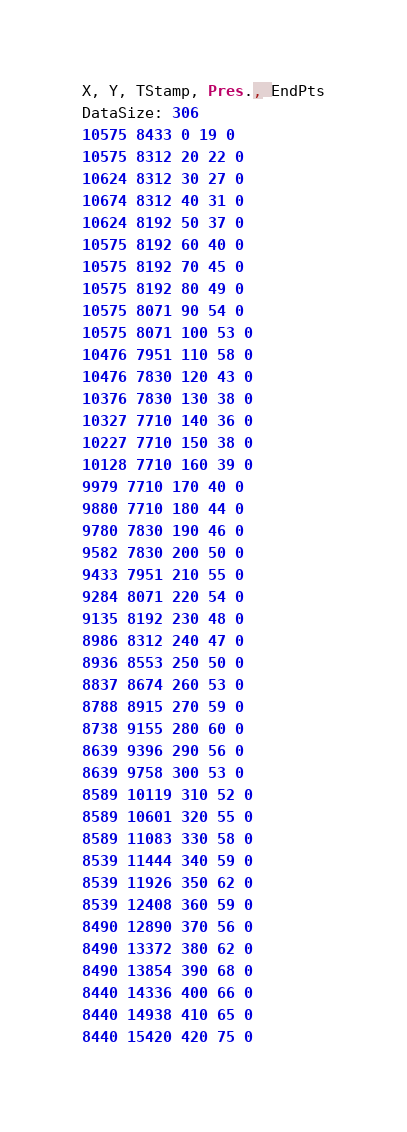<code> <loc_0><loc_0><loc_500><loc_500><_SML_>X, Y, TStamp, Pres., EndPts
DataSize: 306
10575 8433 0 19 0
10575 8312 20 22 0
10624 8312 30 27 0
10674 8312 40 31 0
10624 8192 50 37 0
10575 8192 60 40 0
10575 8192 70 45 0
10575 8192 80 49 0
10575 8071 90 54 0
10575 8071 100 53 0
10476 7951 110 58 0
10476 7830 120 43 0
10376 7830 130 38 0
10327 7710 140 36 0
10227 7710 150 38 0
10128 7710 160 39 0
9979 7710 170 40 0
9880 7710 180 44 0
9780 7830 190 46 0
9582 7830 200 50 0
9433 7951 210 55 0
9284 8071 220 54 0
9135 8192 230 48 0
8986 8312 240 47 0
8936 8553 250 50 0
8837 8674 260 53 0
8788 8915 270 59 0
8738 9155 280 60 0
8639 9396 290 56 0
8639 9758 300 53 0
8589 10119 310 52 0
8589 10601 320 55 0
8589 11083 330 58 0
8539 11444 340 59 0
8539 11926 350 62 0
8539 12408 360 59 0
8490 12890 370 56 0
8490 13372 380 62 0
8490 13854 390 68 0
8440 14336 400 66 0
8440 14938 410 65 0
8440 15420 420 75 0</code> 